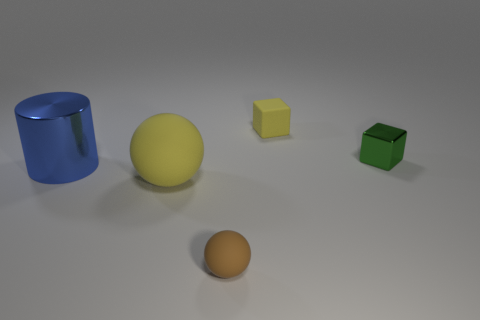Add 3 green things. How many objects exist? 8 Subtract all blocks. How many objects are left? 3 Subtract 0 purple blocks. How many objects are left? 5 Subtract all brown cylinders. Subtract all green cubes. How many cylinders are left? 1 Subtract all shiny cylinders. Subtract all green metallic spheres. How many objects are left? 4 Add 3 yellow cubes. How many yellow cubes are left? 4 Add 1 large metallic things. How many large metallic things exist? 2 